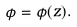<formula> <loc_0><loc_0><loc_500><loc_500>\phi = \phi ( z ) .</formula> 